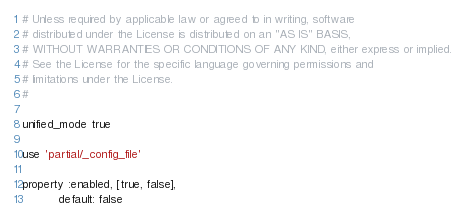Convert code to text. <code><loc_0><loc_0><loc_500><loc_500><_Ruby_># Unless required by applicable law or agreed to in writing, software
# distributed under the License is distributed on an "AS IS" BASIS,
# WITHOUT WARRANTIES OR CONDITIONS OF ANY KIND, either express or implied.
# See the License for the specific language governing permissions and
# limitations under the License.
#

unified_mode true

use 'partial/_config_file'

property :enabled, [true, false],
          default: false
</code> 